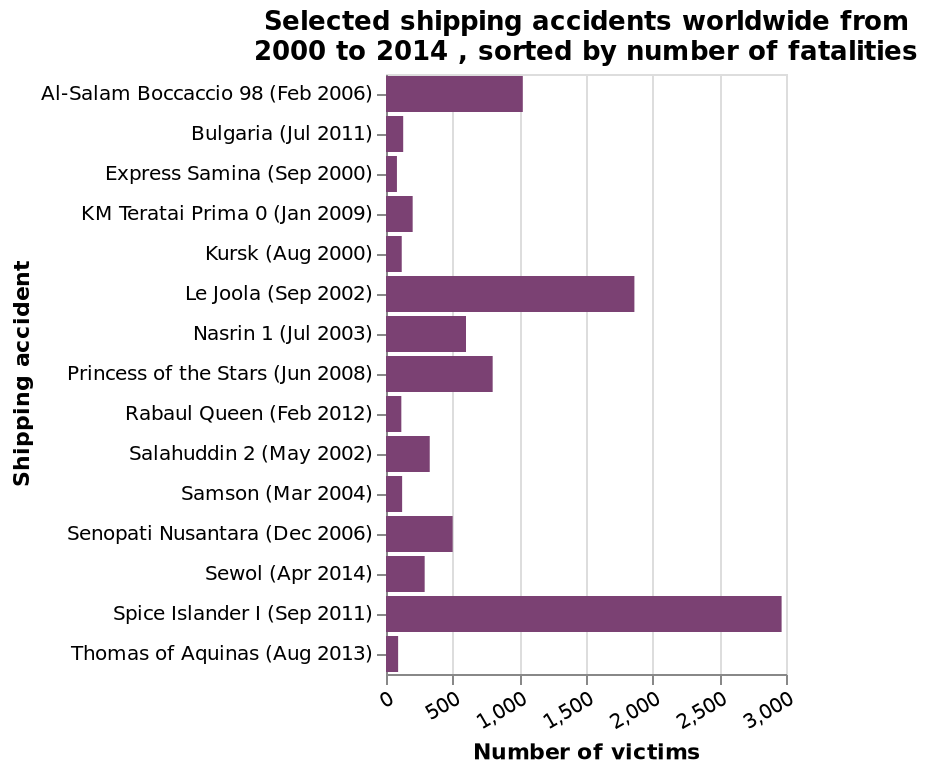<image>
What is the purpose of the bar chart? The purpose of the bar chart is to display selected shipping accidents worldwide from 2000 to 2014, highlighting the number of fatalities and providing a comparative view of different accidents. What is the primary variable represented on the y-axis of the bar chart?  The variable represented on the y-axis of the bar chart is "Shipping accident". Describe the following image in detail Selected shipping accidents worldwide from 2000 to 2014 , sorted by number of fatalities is a bar chart. The x-axis plots Number of victims while the y-axis shows Shipping accident. 